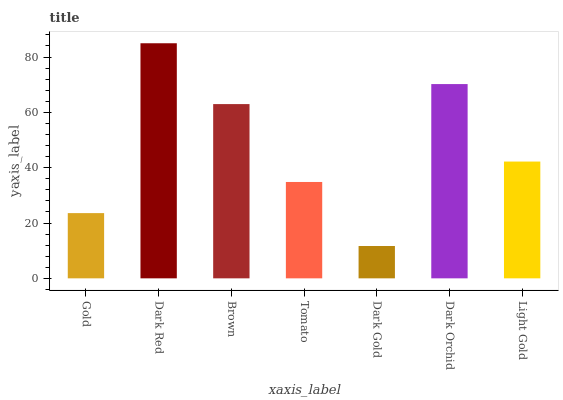Is Dark Gold the minimum?
Answer yes or no. Yes. Is Dark Red the maximum?
Answer yes or no. Yes. Is Brown the minimum?
Answer yes or no. No. Is Brown the maximum?
Answer yes or no. No. Is Dark Red greater than Brown?
Answer yes or no. Yes. Is Brown less than Dark Red?
Answer yes or no. Yes. Is Brown greater than Dark Red?
Answer yes or no. No. Is Dark Red less than Brown?
Answer yes or no. No. Is Light Gold the high median?
Answer yes or no. Yes. Is Light Gold the low median?
Answer yes or no. Yes. Is Gold the high median?
Answer yes or no. No. Is Dark Orchid the low median?
Answer yes or no. No. 